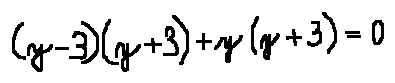Convert formula to latex. <formula><loc_0><loc_0><loc_500><loc_500>( y - 3 ) ( y + 3 ) + y ( y + 3 ) = 0</formula> 